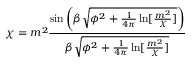<formula> <loc_0><loc_0><loc_500><loc_500>\chi = m ^ { 2 } \frac { \sin \left ( \beta \sqrt { \phi ^ { 2 } + \frac { 1 } { 4 \pi } \ln [ \frac { m ^ { 2 } } { \chi } ] } \right ) } { \beta \sqrt { \phi ^ { 2 } + \frac { 1 } { 4 \pi } \ln [ \frac { m ^ { 2 } } { \chi } ] } }</formula> 